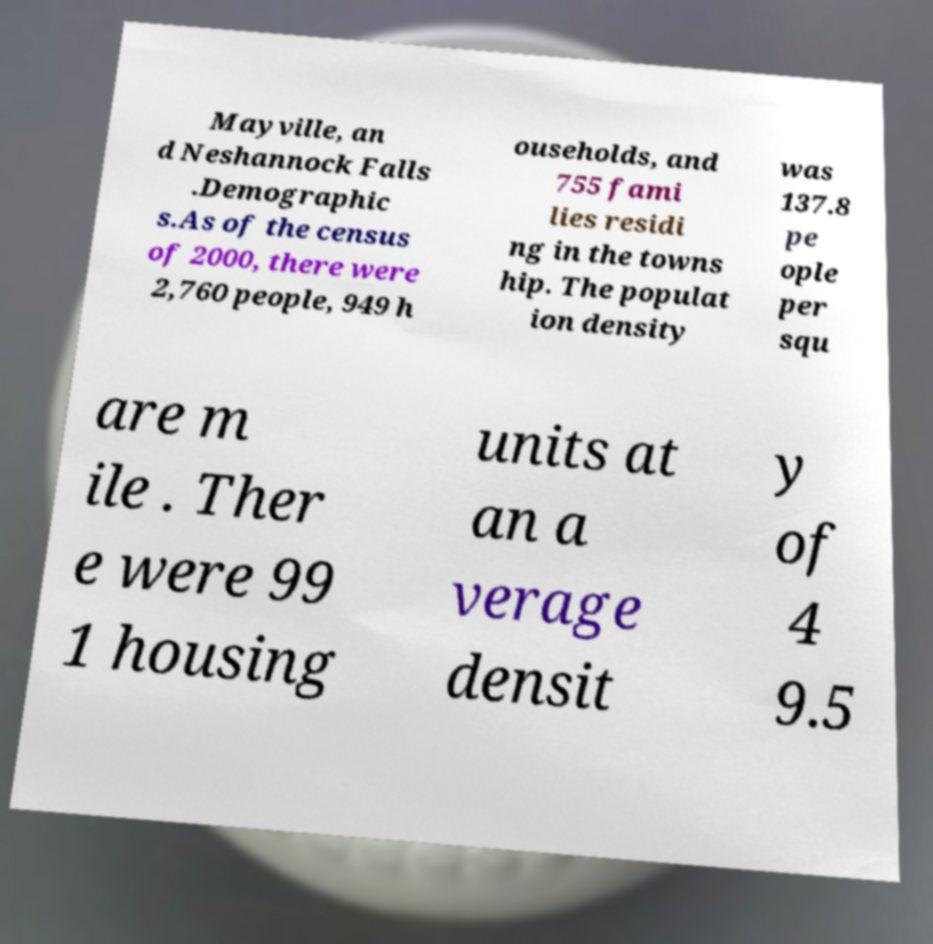Please read and relay the text visible in this image. What does it say? Mayville, an d Neshannock Falls .Demographic s.As of the census of 2000, there were 2,760 people, 949 h ouseholds, and 755 fami lies residi ng in the towns hip. The populat ion density was 137.8 pe ople per squ are m ile . Ther e were 99 1 housing units at an a verage densit y of 4 9.5 